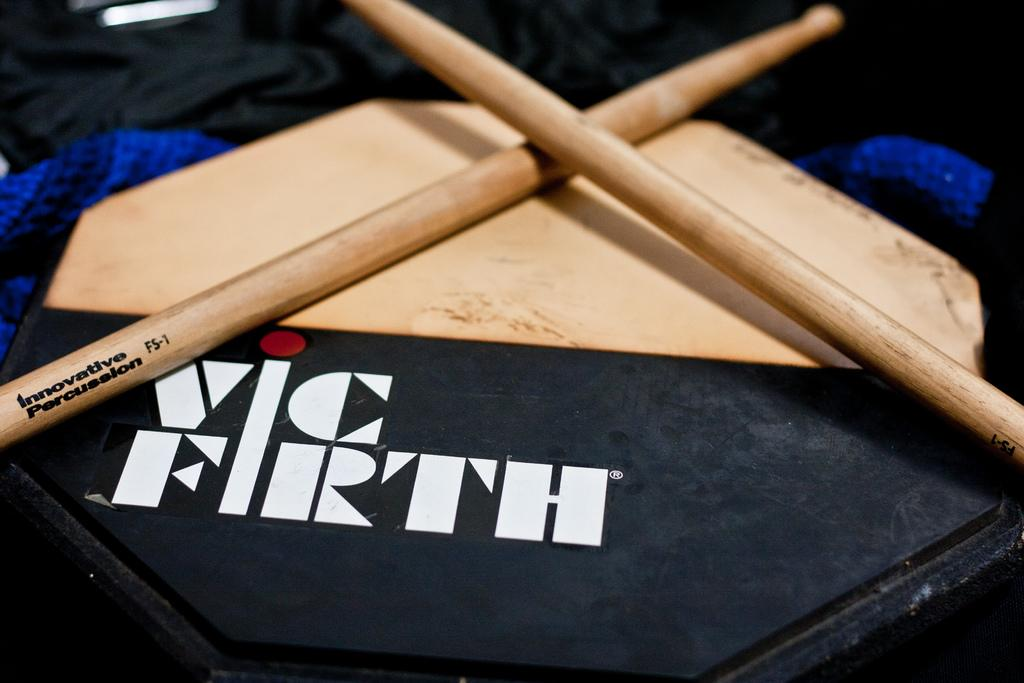What type of material is present in the image? There is wood material in the image. What is placed on the wood material? Black color clothes are placed on the wood material. How does the arrangement of the wood material and clothes appear? The arrangement of the wood material and clothes resembles a box. Can you tell me what time the watch is showing in the image? There is no watch present in the image. How many robins can be seen paying attention to the clothes in the image? There are no robins present in the image. 